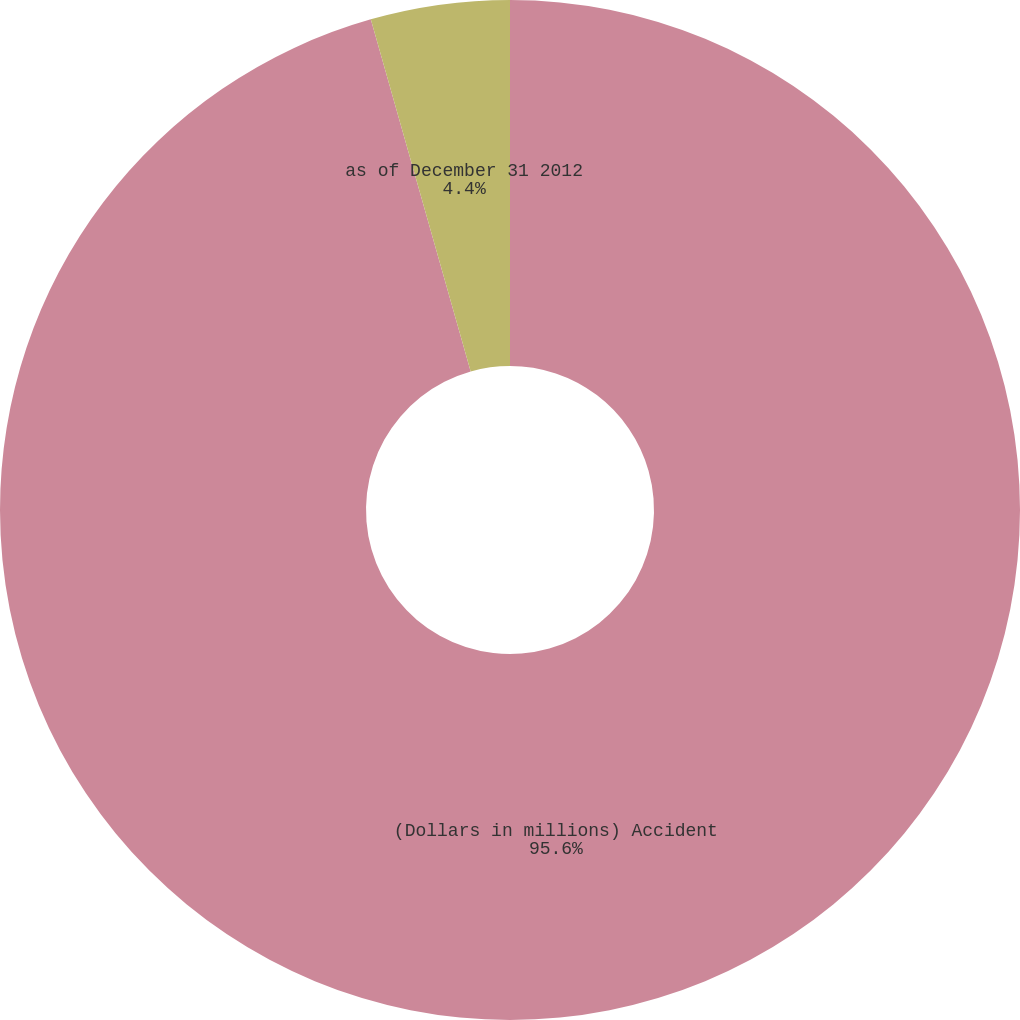Convert chart to OTSL. <chart><loc_0><loc_0><loc_500><loc_500><pie_chart><fcel>(Dollars in millions) Accident<fcel>as of December 31 2012<nl><fcel>95.6%<fcel>4.4%<nl></chart> 